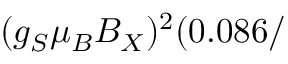Convert formula to latex. <formula><loc_0><loc_0><loc_500><loc_500>( g _ { S } \mu _ { B } B _ { X } ) ^ { 2 } ( 0 . 0 8 6 /</formula> 